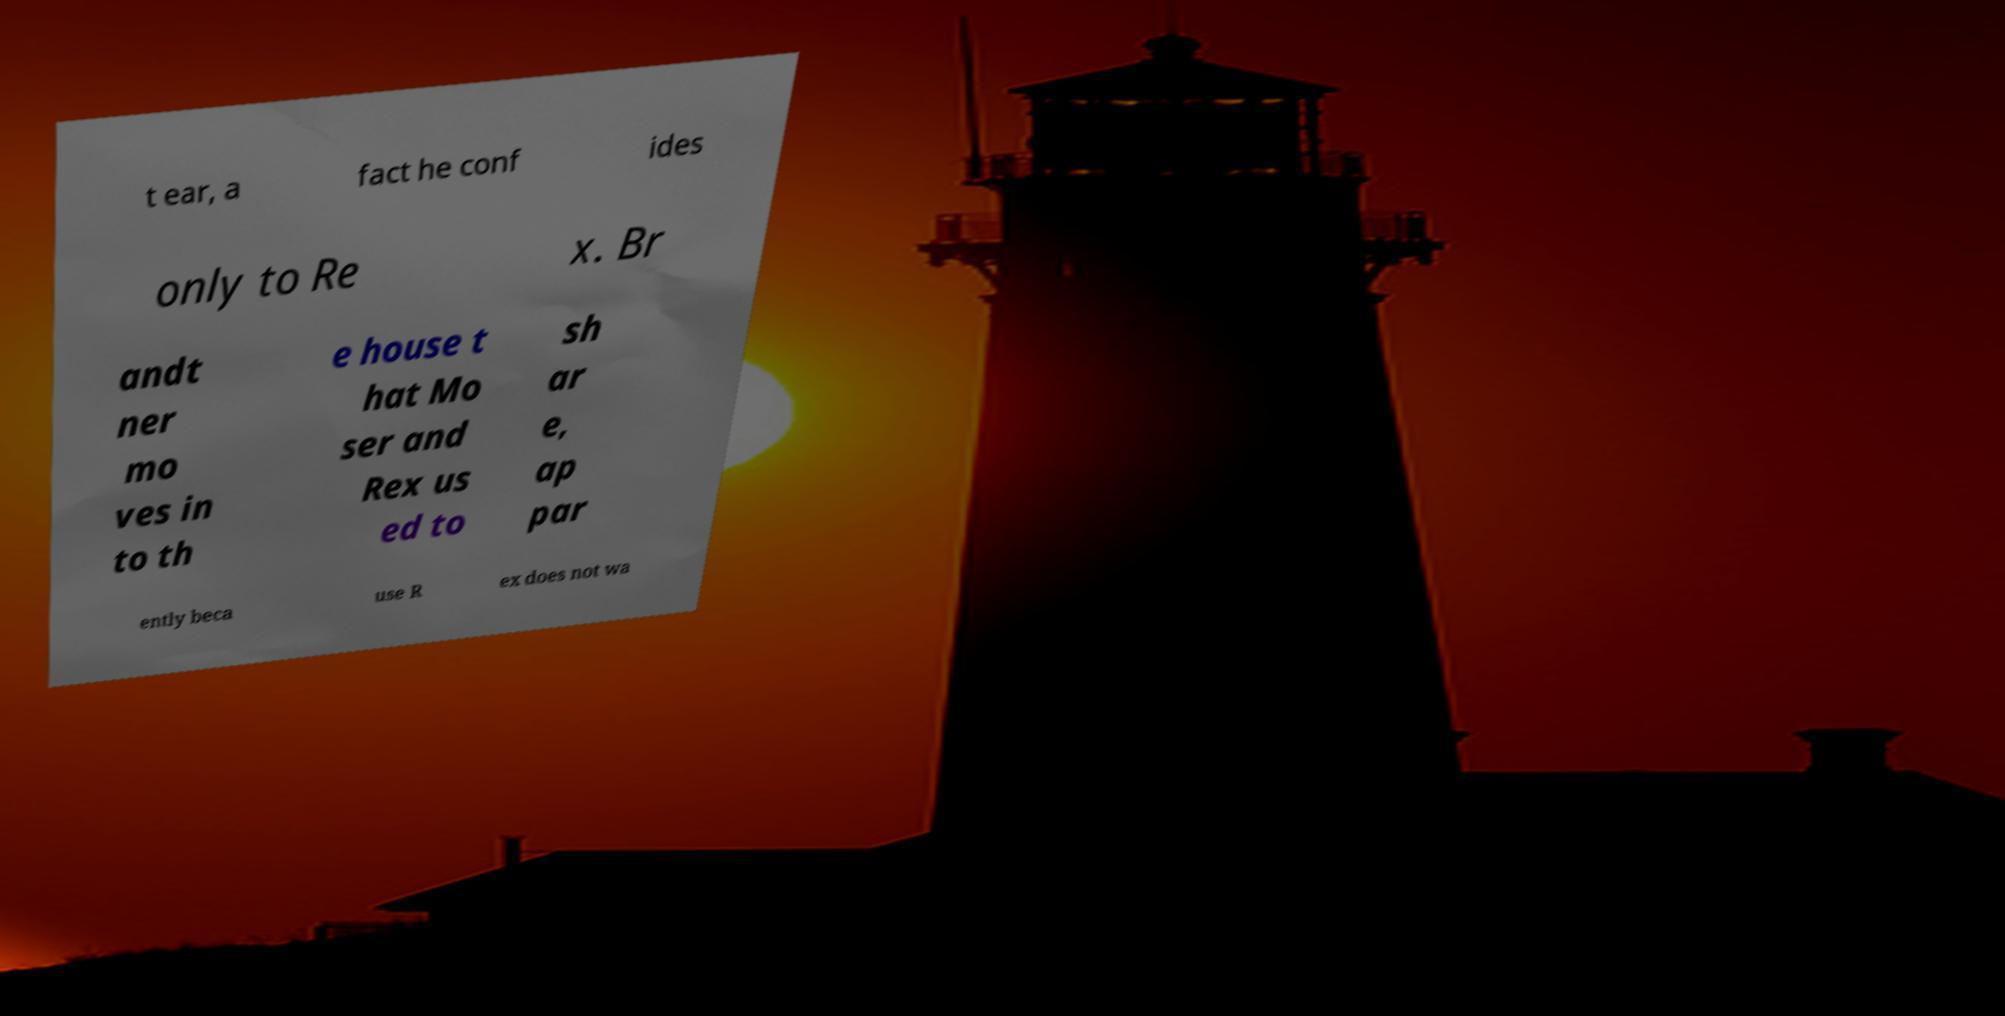Please read and relay the text visible in this image. What does it say? t ear, a fact he conf ides only to Re x. Br andt ner mo ves in to th e house t hat Mo ser and Rex us ed to sh ar e, ap par ently beca use R ex does not wa 